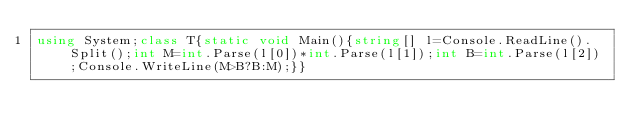Convert code to text. <code><loc_0><loc_0><loc_500><loc_500><_C#_>using System;class T{static void Main(){string[] l=Console.ReadLine().Split();int M=int.Parse(l[0])*int.Parse(l[1]);int B=int.Parse(l[2]);Console.WriteLine(M>B?B:M);}}</code> 